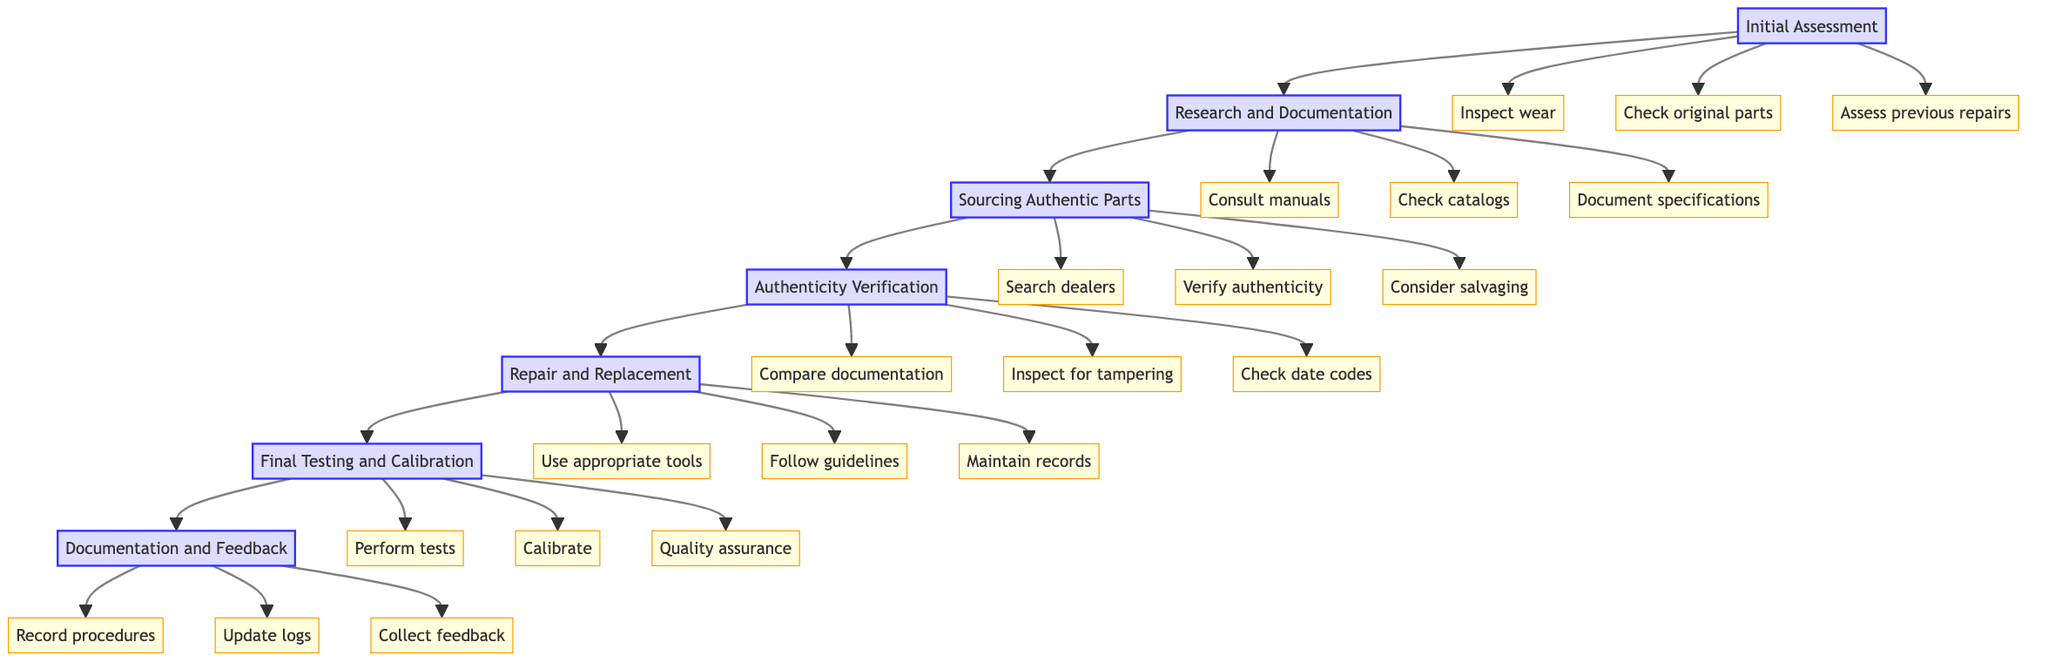What is the first step in the pathway? The first step in the pathway is "Initial Assessment". This is determined by looking at the top of the diagram where the sequence begins.
Answer: Initial Assessment How many actions are listed under the "Research and Documentation" step? Under the "Research and Documentation" step, there are three actions visible in the flowchart. This is obtained by counting the actions branching out from the step node.
Answer: 3 What step follows "Authenticity Verification"? The step that follows "Authenticity Verification" in the sequence is "Repair and Replacement". This is identified by tracing the arrow leading from the "Authenticity Verification" node.
Answer: Repair and Replacement Which step includes the action of "Search dealers"? The action "Search dealers" is included in the "Sourcing Authentic Parts" step. This can be confirmed by finding the action branches connected to that step node.
Answer: Sourcing Authentic Parts What is the last step in the pathway? The last step in the pathway is "Documentation and Feedback". This is found at the end of the sequence in the flowchart.
Answer: Documentation and Feedback How many steps are in the pathway in total? There are seven steps in total in the pathway, identified by counting all the main steps drawn in the diagram.
Answer: 7 Which action is related to ensuring that the original specifications are maintained during testing? The action related to maintaining the original specifications during testing is "Calibrate". This can be found under the "Final Testing and Calibration" step.
Answer: Calibrate What does the step "Final Testing and Calibration" involve with the audio signals? This step involves performing functional tests with audio signals. The connection is established by reviewing the specific actions associated with "Final Testing and Calibration".
Answer: Perform functional tests with audio signals 